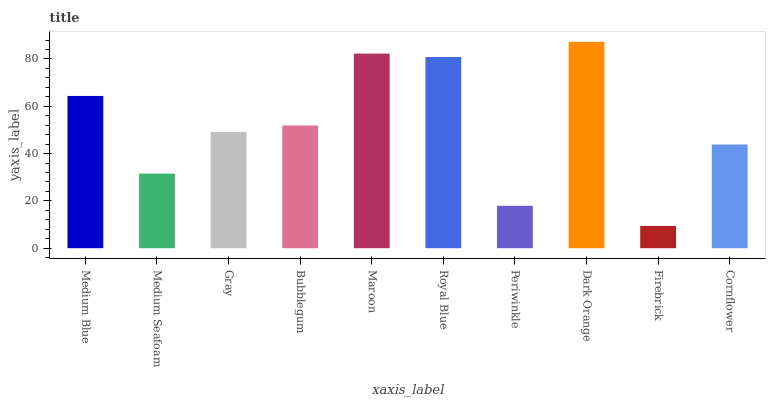Is Firebrick the minimum?
Answer yes or no. Yes. Is Dark Orange the maximum?
Answer yes or no. Yes. Is Medium Seafoam the minimum?
Answer yes or no. No. Is Medium Seafoam the maximum?
Answer yes or no. No. Is Medium Blue greater than Medium Seafoam?
Answer yes or no. Yes. Is Medium Seafoam less than Medium Blue?
Answer yes or no. Yes. Is Medium Seafoam greater than Medium Blue?
Answer yes or no. No. Is Medium Blue less than Medium Seafoam?
Answer yes or no. No. Is Bubblegum the high median?
Answer yes or no. Yes. Is Gray the low median?
Answer yes or no. Yes. Is Cornflower the high median?
Answer yes or no. No. Is Medium Blue the low median?
Answer yes or no. No. 